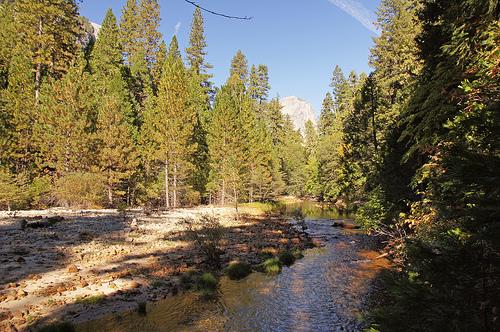<image>
Is the tree on the river? No. The tree is not positioned on the river. They may be near each other, but the tree is not supported by or resting on top of the river. Is the sky on the water? No. The sky is not positioned on the water. They may be near each other, but the sky is not supported by or resting on top of the water. Where is the water in relation to the trees? Is it under the trees? No. The water is not positioned under the trees. The vertical relationship between these objects is different. 